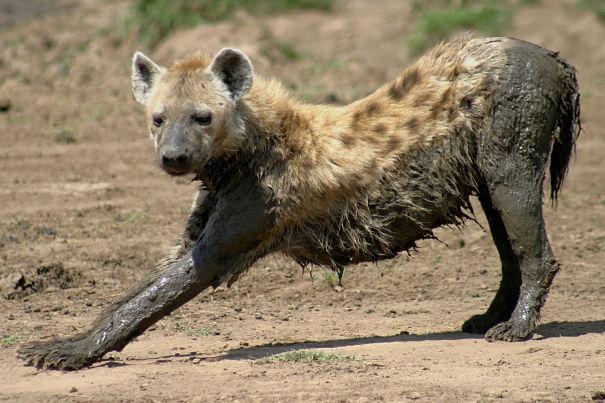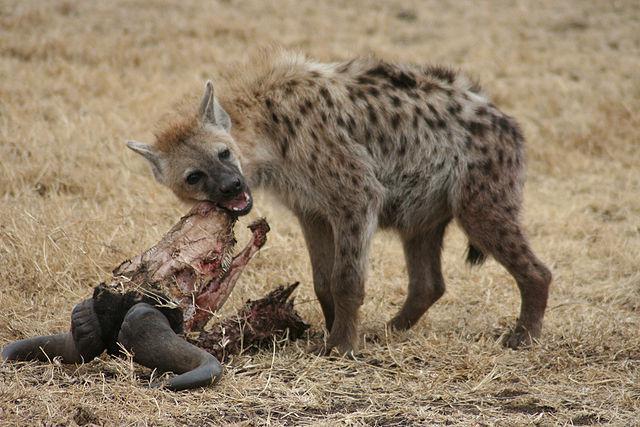The first image is the image on the left, the second image is the image on the right. Considering the images on both sides, is "All of the images contain only one hyena." valid? Answer yes or no. Yes. 